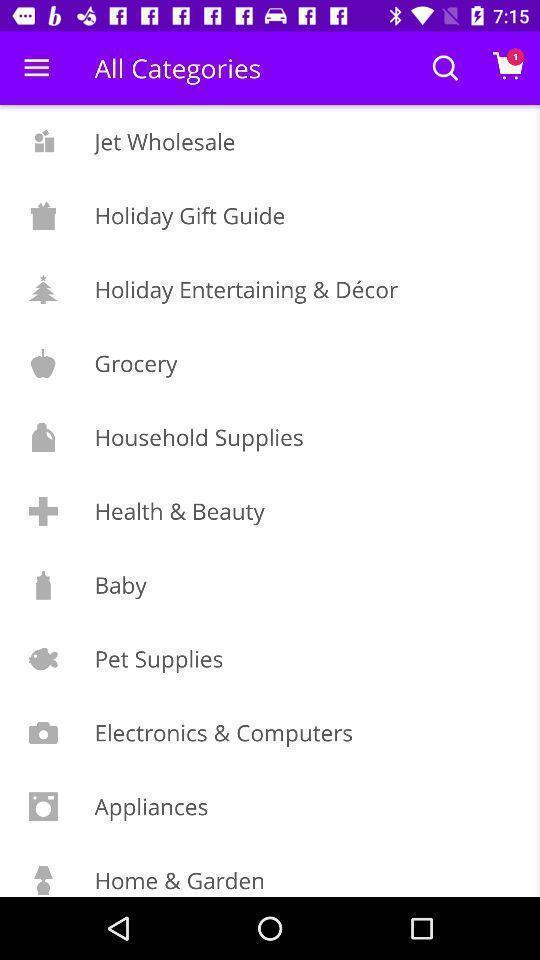Give me a summary of this screen capture. Page that displaying shopping application. 